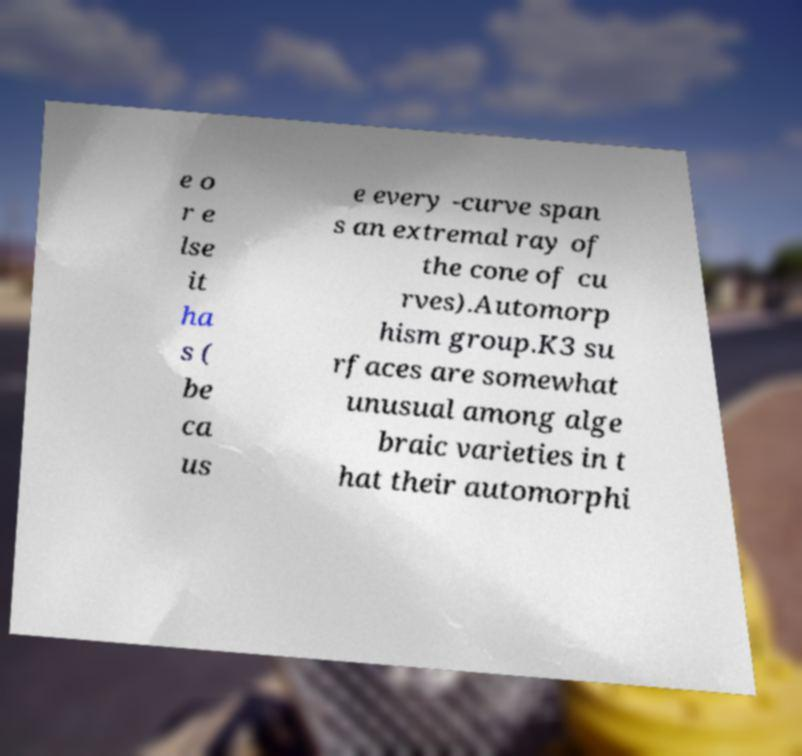There's text embedded in this image that I need extracted. Can you transcribe it verbatim? e o r e lse it ha s ( be ca us e every -curve span s an extremal ray of the cone of cu rves).Automorp hism group.K3 su rfaces are somewhat unusual among alge braic varieties in t hat their automorphi 